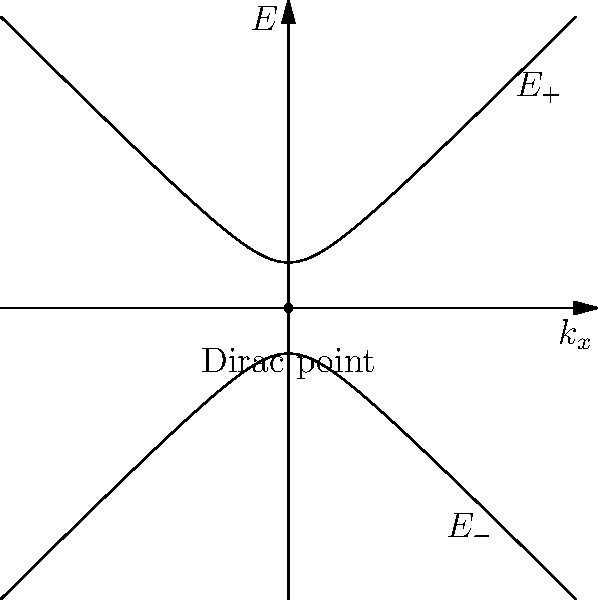Consider the energy dispersion relation near a Dirac point in a disordered graphene sheet, given by $E_{\pm}(k) = \pm\sqrt{v_F^2k^2 + \Delta^2}$, where $v_F$ is the Fermi velocity, $k$ is the wave vector, and $\Delta$ represents the disorder-induced gap. Calculate the group velocity vector $\vec{v}_g$ for electrons in the conduction band ($E_+$) at a point where $|\vec{k}| = k_0$ and $\Delta = 0.1v_Fk_0$. To find the group velocity vector, we need to follow these steps:

1) The group velocity is defined as $\vec{v}_g = \nabla_k E(k)$. For a 2D system like graphene, this means:

   $\vec{v}_g = (\frac{\partial E}{\partial k_x}, \frac{\partial E}{\partial k_y})$

2) We're considering the conduction band, so we use $E_+(k) = \sqrt{v_F^2k^2 + \Delta^2}$

3) Let's calculate $\frac{\partial E_+}{\partial k_x}$:
   
   $\frac{\partial E_+}{\partial k_x} = \frac{1}{2\sqrt{v_F^2k^2 + \Delta^2}} \cdot 2v_F^2k_x = \frac{v_F^2k_x}{\sqrt{v_F^2k^2 + \Delta^2}}$

4) Similarly for $\frac{\partial E_+}{\partial k_y}$:
   
   $\frac{\partial E_+}{\partial k_y} = \frac{v_F^2k_y}{\sqrt{v_F^2k^2 + \Delta^2}}$

5) Therefore, the group velocity vector is:

   $\vec{v}_g = \frac{v_F^2\vec{k}}{\sqrt{v_F^2k^2 + \Delta^2}}$

6) Now, we substitute the given values: $|\vec{k}| = k_0$ and $\Delta = 0.1v_Fk_0$

   $\vec{v}_g = \frac{v_F^2k_0}{\sqrt{v_F^2k_0^2 + (0.1v_Fk_0)^2}} \cdot \frac{\vec{k}}{k_0}$

7) Simplify:

   $\vec{v}_g = \frac{v_F^2}{\sqrt{v_F^2 + 0.01v_F^2}} \cdot \frac{\vec{k}}{k_0} = \frac{v_F}{\sqrt{1.01}} \cdot \frac{\vec{k}}{k_0}$

Thus, the magnitude of the group velocity is $\frac{v_F}{\sqrt{1.01}}$, and its direction is along $\vec{k}$.
Answer: $\vec{v}_g = \frac{v_F}{\sqrt{1.01}} \cdot \frac{\vec{k}}{k_0}$ 